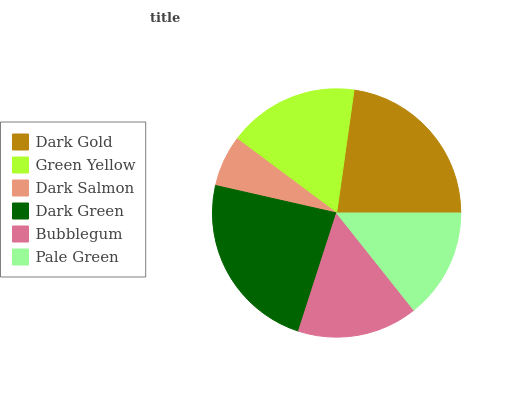Is Dark Salmon the minimum?
Answer yes or no. Yes. Is Dark Green the maximum?
Answer yes or no. Yes. Is Green Yellow the minimum?
Answer yes or no. No. Is Green Yellow the maximum?
Answer yes or no. No. Is Dark Gold greater than Green Yellow?
Answer yes or no. Yes. Is Green Yellow less than Dark Gold?
Answer yes or no. Yes. Is Green Yellow greater than Dark Gold?
Answer yes or no. No. Is Dark Gold less than Green Yellow?
Answer yes or no. No. Is Green Yellow the high median?
Answer yes or no. Yes. Is Bubblegum the low median?
Answer yes or no. Yes. Is Dark Green the high median?
Answer yes or no. No. Is Dark Green the low median?
Answer yes or no. No. 